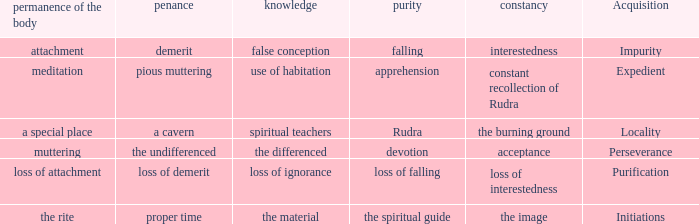 what's the permanence of the body where purity is apprehension Meditation. 